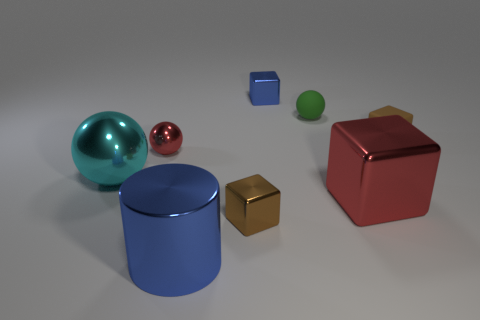There is a ball that is on the right side of the big cylinder; how big is it?
Give a very brief answer. Small. How many large balls are behind the large object that is to the left of the blue metallic object that is in front of the brown rubber thing?
Your response must be concise. 0. Do the large block and the tiny shiny ball have the same color?
Provide a short and direct response. Yes. How many shiny objects are both to the right of the blue cylinder and in front of the red cube?
Provide a short and direct response. 1. What shape is the brown thing that is behind the tiny shiny ball?
Offer a very short reply. Cube. Are there fewer tiny brown things that are on the right side of the big red object than red objects that are in front of the brown shiny thing?
Your response must be concise. No. Does the blue thing that is behind the large cyan metal object have the same material as the tiny sphere behind the small brown matte object?
Your answer should be very brief. No. The tiny red thing has what shape?
Provide a short and direct response. Sphere. Are there more brown metal blocks that are on the right side of the tiny red shiny ball than large blue shiny objects that are left of the big metal sphere?
Your answer should be compact. Yes. Do the red object that is on the left side of the big cylinder and the green thing that is behind the large shiny sphere have the same shape?
Keep it short and to the point. Yes. 